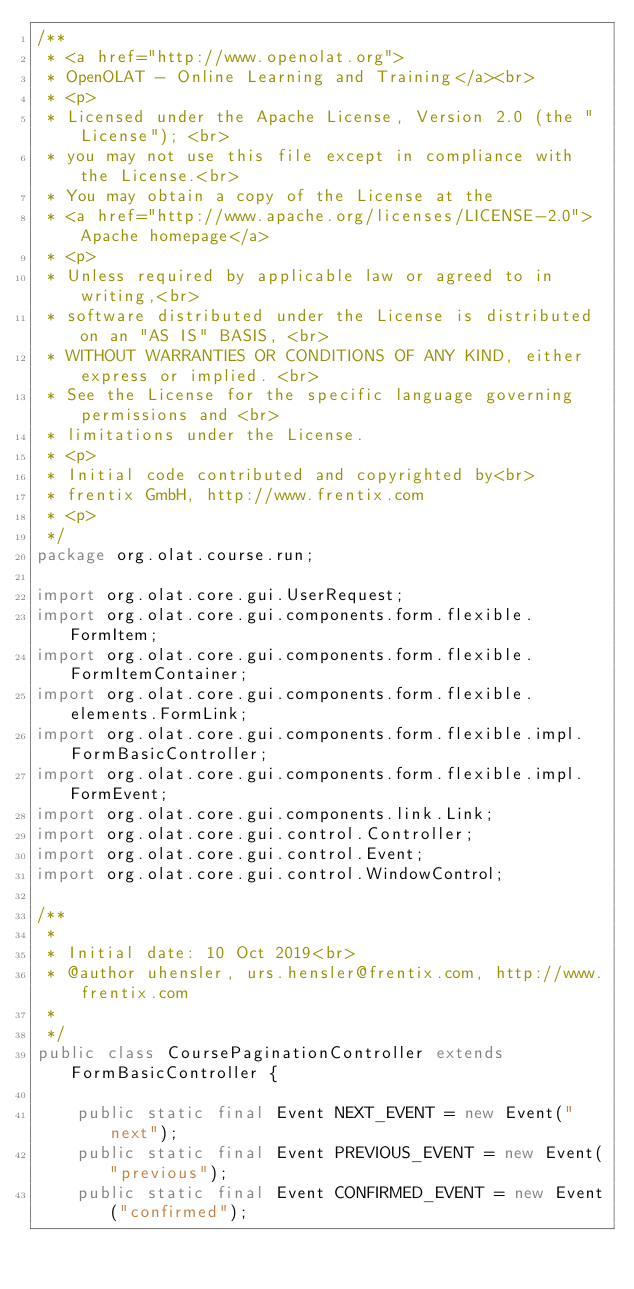Convert code to text. <code><loc_0><loc_0><loc_500><loc_500><_Java_>/**
 * <a href="http://www.openolat.org">
 * OpenOLAT - Online Learning and Training</a><br>
 * <p>
 * Licensed under the Apache License, Version 2.0 (the "License"); <br>
 * you may not use this file except in compliance with the License.<br>
 * You may obtain a copy of the License at the
 * <a href="http://www.apache.org/licenses/LICENSE-2.0">Apache homepage</a>
 * <p>
 * Unless required by applicable law or agreed to in writing,<br>
 * software distributed under the License is distributed on an "AS IS" BASIS, <br>
 * WITHOUT WARRANTIES OR CONDITIONS OF ANY KIND, either express or implied. <br>
 * See the License for the specific language governing permissions and <br>
 * limitations under the License.
 * <p>
 * Initial code contributed and copyrighted by<br>
 * frentix GmbH, http://www.frentix.com
 * <p>
 */
package org.olat.course.run;

import org.olat.core.gui.UserRequest;
import org.olat.core.gui.components.form.flexible.FormItem;
import org.olat.core.gui.components.form.flexible.FormItemContainer;
import org.olat.core.gui.components.form.flexible.elements.FormLink;
import org.olat.core.gui.components.form.flexible.impl.FormBasicController;
import org.olat.core.gui.components.form.flexible.impl.FormEvent;
import org.olat.core.gui.components.link.Link;
import org.olat.core.gui.control.Controller;
import org.olat.core.gui.control.Event;
import org.olat.core.gui.control.WindowControl;

/**
 * 
 * Initial date: 10 Oct 2019<br>
 * @author uhensler, urs.hensler@frentix.com, http://www.frentix.com
 *
 */
public class CoursePaginationController extends FormBasicController {
	
	public static final Event NEXT_EVENT = new Event("next");
	public static final Event PREVIOUS_EVENT = new Event("previous");
	public static final Event CONFIRMED_EVENT = new Event("confirmed");</code> 